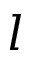<formula> <loc_0><loc_0><loc_500><loc_500>l</formula> 